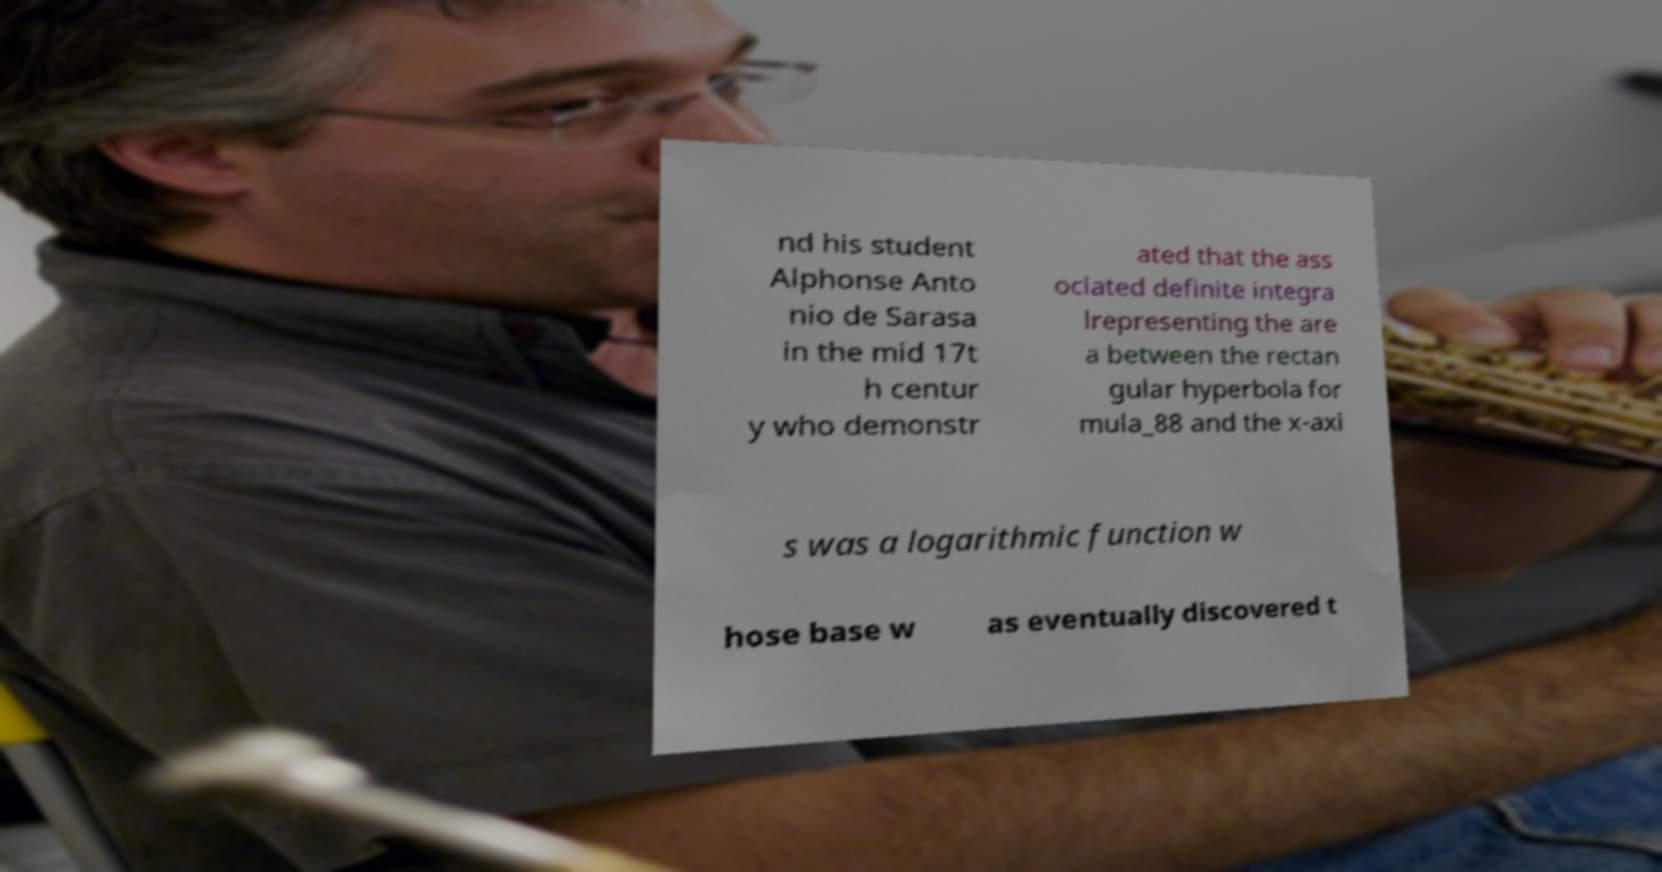Could you extract and type out the text from this image? nd his student Alphonse Anto nio de Sarasa in the mid 17t h centur y who demonstr ated that the ass ociated definite integra lrepresenting the are a between the rectan gular hyperbola for mula_88 and the x-axi s was a logarithmic function w hose base w as eventually discovered t 